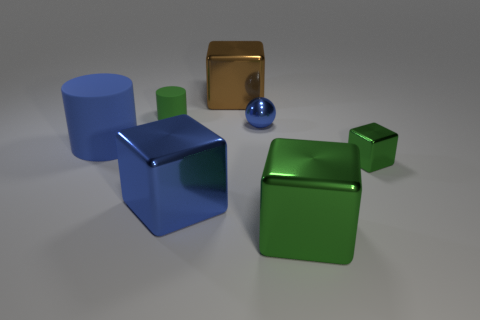Add 1 purple cylinders. How many objects exist? 8 Subtract all spheres. How many objects are left? 6 Subtract all tiny rubber cylinders. Subtract all green objects. How many objects are left? 3 Add 4 blue balls. How many blue balls are left? 5 Add 7 small things. How many small things exist? 10 Subtract 0 yellow balls. How many objects are left? 7 